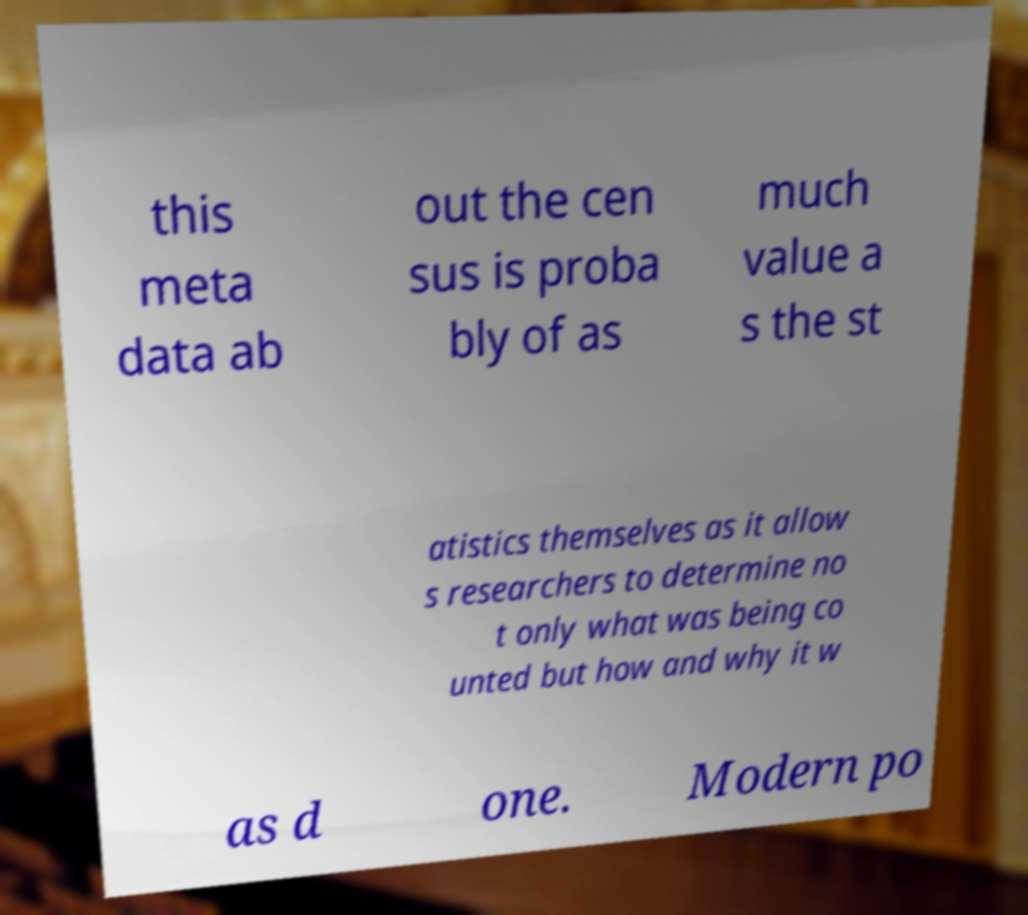Please identify and transcribe the text found in this image. this meta data ab out the cen sus is proba bly of as much value a s the st atistics themselves as it allow s researchers to determine no t only what was being co unted but how and why it w as d one. Modern po 